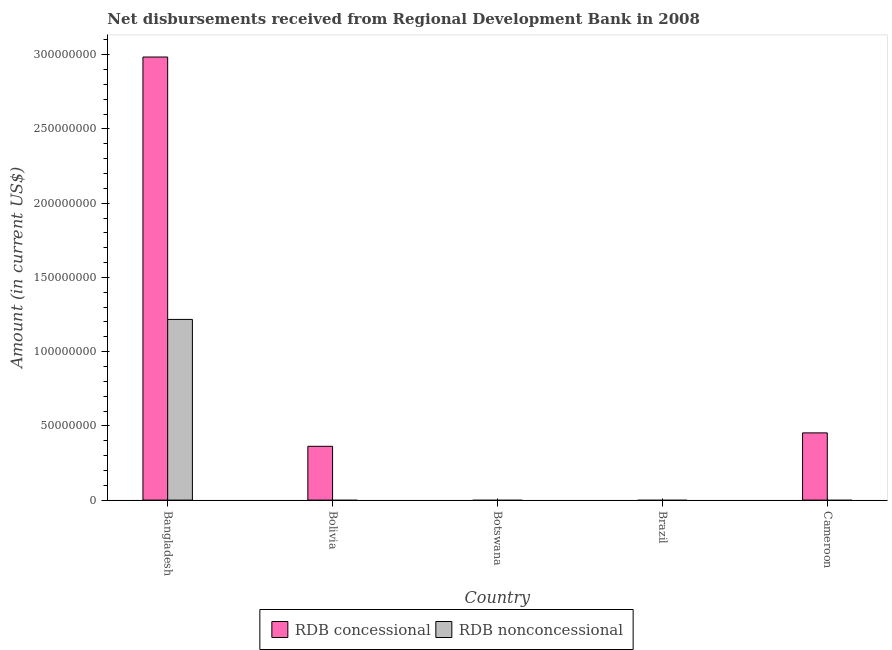Are the number of bars per tick equal to the number of legend labels?
Give a very brief answer. No. What is the label of the 4th group of bars from the left?
Your response must be concise. Brazil. What is the net non concessional disbursements from rdb in Brazil?
Keep it short and to the point. 0. Across all countries, what is the maximum net concessional disbursements from rdb?
Provide a succinct answer. 2.98e+08. In which country was the net non concessional disbursements from rdb maximum?
Your response must be concise. Bangladesh. What is the total net concessional disbursements from rdb in the graph?
Your answer should be compact. 3.80e+08. What is the difference between the net concessional disbursements from rdb in Bangladesh and that in Cameroon?
Keep it short and to the point. 2.53e+08. What is the difference between the net concessional disbursements from rdb in Bolivia and the net non concessional disbursements from rdb in Brazil?
Give a very brief answer. 3.62e+07. What is the average net non concessional disbursements from rdb per country?
Provide a succinct answer. 2.43e+07. What is the difference between the net concessional disbursements from rdb and net non concessional disbursements from rdb in Bangladesh?
Your answer should be very brief. 1.77e+08. In how many countries, is the net non concessional disbursements from rdb greater than 210000000 US$?
Ensure brevity in your answer.  0. Is the net concessional disbursements from rdb in Bangladesh less than that in Cameroon?
Provide a short and direct response. No. What is the difference between the highest and the second highest net concessional disbursements from rdb?
Offer a very short reply. 2.53e+08. What is the difference between the highest and the lowest net non concessional disbursements from rdb?
Your answer should be compact. 1.22e+08. In how many countries, is the net non concessional disbursements from rdb greater than the average net non concessional disbursements from rdb taken over all countries?
Provide a short and direct response. 1. Are the values on the major ticks of Y-axis written in scientific E-notation?
Ensure brevity in your answer.  No. How are the legend labels stacked?
Keep it short and to the point. Horizontal. What is the title of the graph?
Your response must be concise. Net disbursements received from Regional Development Bank in 2008. What is the label or title of the Y-axis?
Offer a terse response. Amount (in current US$). What is the Amount (in current US$) in RDB concessional in Bangladesh?
Keep it short and to the point. 2.98e+08. What is the Amount (in current US$) in RDB nonconcessional in Bangladesh?
Your answer should be compact. 1.22e+08. What is the Amount (in current US$) in RDB concessional in Bolivia?
Offer a terse response. 3.62e+07. What is the Amount (in current US$) in RDB nonconcessional in Botswana?
Provide a succinct answer. 0. What is the Amount (in current US$) in RDB concessional in Brazil?
Ensure brevity in your answer.  0. What is the Amount (in current US$) of RDB concessional in Cameroon?
Ensure brevity in your answer.  4.53e+07. What is the Amount (in current US$) of RDB nonconcessional in Cameroon?
Your response must be concise. 0. Across all countries, what is the maximum Amount (in current US$) in RDB concessional?
Your answer should be very brief. 2.98e+08. Across all countries, what is the maximum Amount (in current US$) in RDB nonconcessional?
Provide a short and direct response. 1.22e+08. Across all countries, what is the minimum Amount (in current US$) in RDB concessional?
Make the answer very short. 0. Across all countries, what is the minimum Amount (in current US$) in RDB nonconcessional?
Your response must be concise. 0. What is the total Amount (in current US$) in RDB concessional in the graph?
Keep it short and to the point. 3.80e+08. What is the total Amount (in current US$) in RDB nonconcessional in the graph?
Provide a succinct answer. 1.22e+08. What is the difference between the Amount (in current US$) of RDB concessional in Bangladesh and that in Bolivia?
Make the answer very short. 2.62e+08. What is the difference between the Amount (in current US$) in RDB concessional in Bangladesh and that in Cameroon?
Your answer should be very brief. 2.53e+08. What is the difference between the Amount (in current US$) of RDB concessional in Bolivia and that in Cameroon?
Your answer should be compact. -9.05e+06. What is the average Amount (in current US$) of RDB concessional per country?
Ensure brevity in your answer.  7.60e+07. What is the average Amount (in current US$) of RDB nonconcessional per country?
Offer a terse response. 2.43e+07. What is the difference between the Amount (in current US$) of RDB concessional and Amount (in current US$) of RDB nonconcessional in Bangladesh?
Your answer should be compact. 1.77e+08. What is the ratio of the Amount (in current US$) in RDB concessional in Bangladesh to that in Bolivia?
Your answer should be very brief. 8.24. What is the ratio of the Amount (in current US$) of RDB concessional in Bangladesh to that in Cameroon?
Give a very brief answer. 6.59. What is the ratio of the Amount (in current US$) in RDB concessional in Bolivia to that in Cameroon?
Ensure brevity in your answer.  0.8. What is the difference between the highest and the second highest Amount (in current US$) in RDB concessional?
Ensure brevity in your answer.  2.53e+08. What is the difference between the highest and the lowest Amount (in current US$) in RDB concessional?
Provide a succinct answer. 2.98e+08. What is the difference between the highest and the lowest Amount (in current US$) of RDB nonconcessional?
Keep it short and to the point. 1.22e+08. 